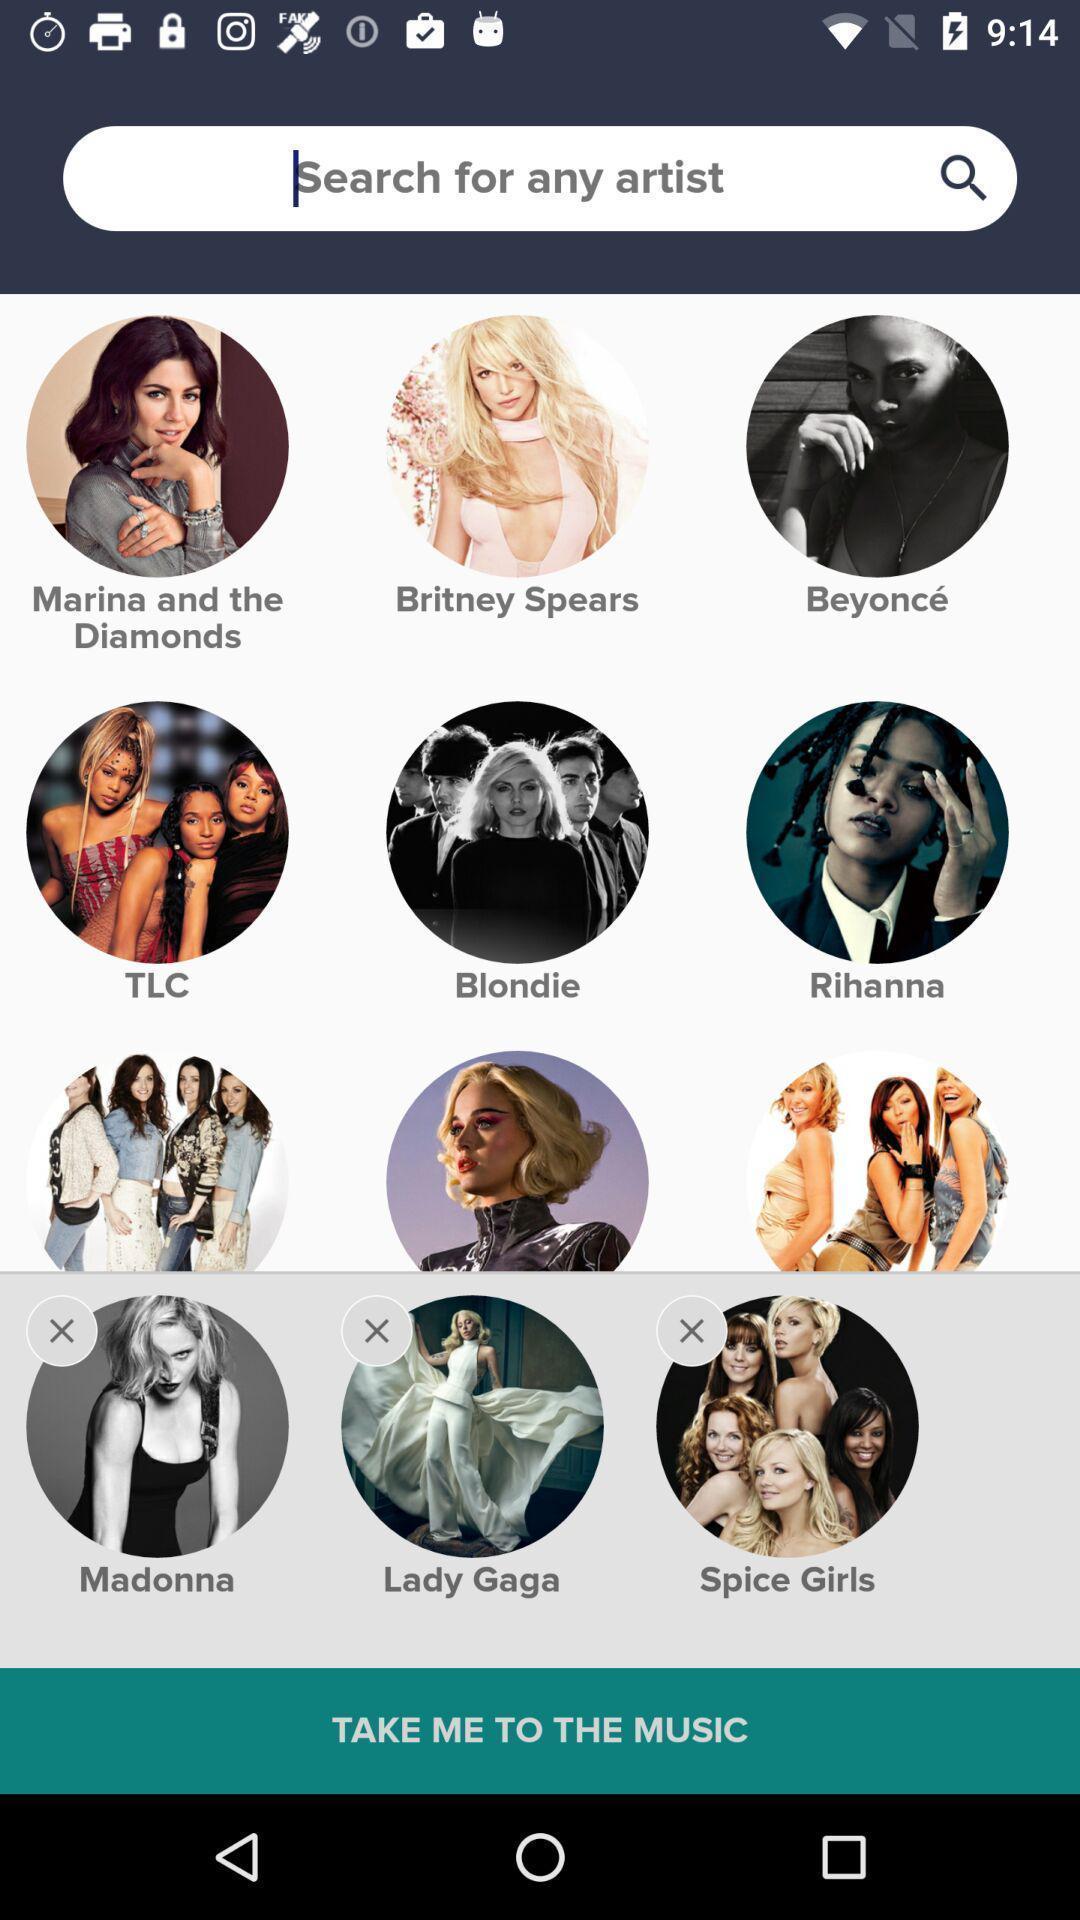Summarize the information in this screenshot. Screen asking to search for any artist. 